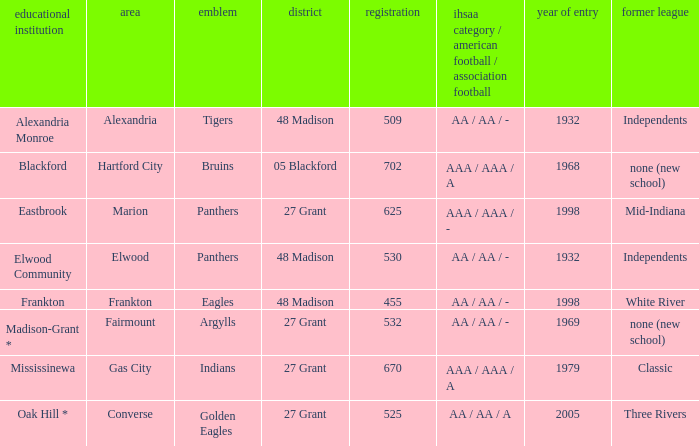What is teh ihsaa class/football/soccer when the location is alexandria? AA / AA / -. 